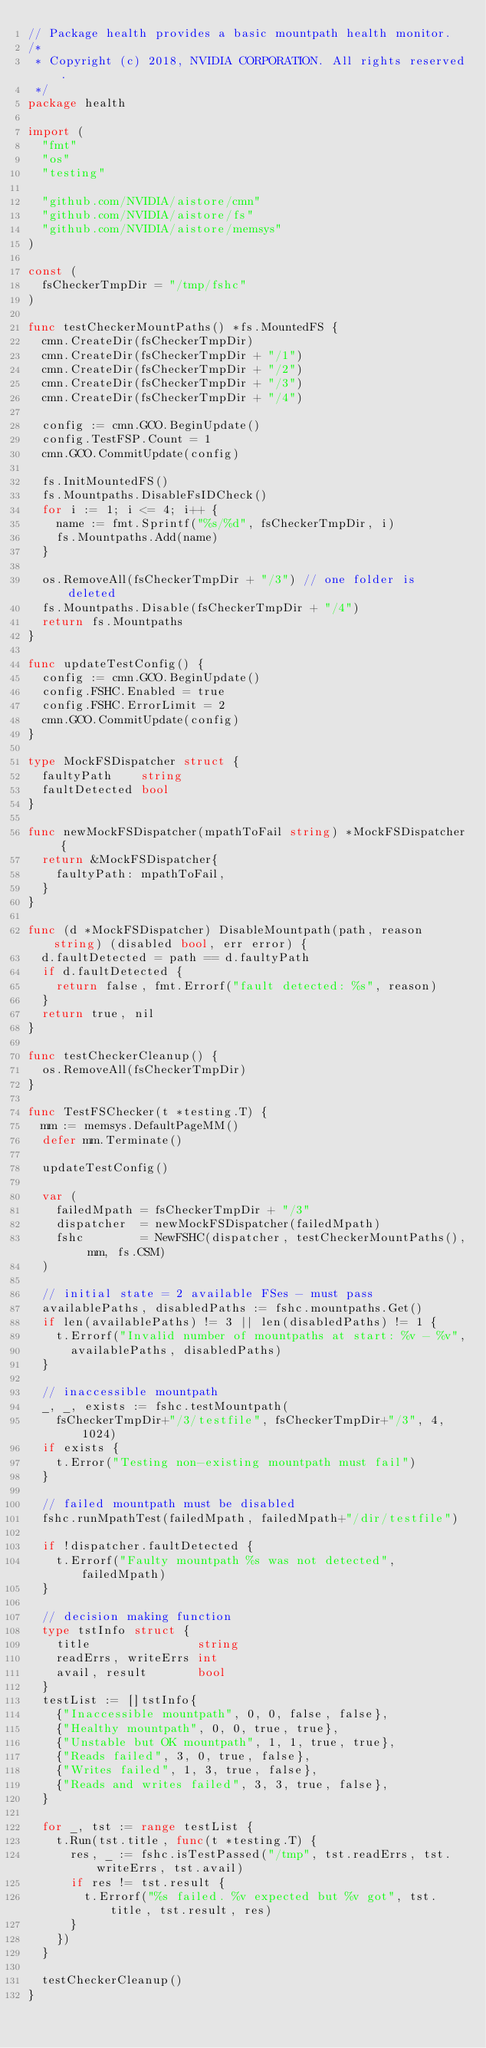<code> <loc_0><loc_0><loc_500><loc_500><_Go_>// Package health provides a basic mountpath health monitor.
/*
 * Copyright (c) 2018, NVIDIA CORPORATION. All rights reserved.
 */
package health

import (
	"fmt"
	"os"
	"testing"

	"github.com/NVIDIA/aistore/cmn"
	"github.com/NVIDIA/aistore/fs"
	"github.com/NVIDIA/aistore/memsys"
)

const (
	fsCheckerTmpDir = "/tmp/fshc"
)

func testCheckerMountPaths() *fs.MountedFS {
	cmn.CreateDir(fsCheckerTmpDir)
	cmn.CreateDir(fsCheckerTmpDir + "/1")
	cmn.CreateDir(fsCheckerTmpDir + "/2")
	cmn.CreateDir(fsCheckerTmpDir + "/3")
	cmn.CreateDir(fsCheckerTmpDir + "/4")

	config := cmn.GCO.BeginUpdate()
	config.TestFSP.Count = 1
	cmn.GCO.CommitUpdate(config)

	fs.InitMountedFS()
	fs.Mountpaths.DisableFsIDCheck()
	for i := 1; i <= 4; i++ {
		name := fmt.Sprintf("%s/%d", fsCheckerTmpDir, i)
		fs.Mountpaths.Add(name)
	}

	os.RemoveAll(fsCheckerTmpDir + "/3") // one folder is deleted
	fs.Mountpaths.Disable(fsCheckerTmpDir + "/4")
	return fs.Mountpaths
}

func updateTestConfig() {
	config := cmn.GCO.BeginUpdate()
	config.FSHC.Enabled = true
	config.FSHC.ErrorLimit = 2
	cmn.GCO.CommitUpdate(config)
}

type MockFSDispatcher struct {
	faultyPath    string
	faultDetected bool
}

func newMockFSDispatcher(mpathToFail string) *MockFSDispatcher {
	return &MockFSDispatcher{
		faultyPath: mpathToFail,
	}
}

func (d *MockFSDispatcher) DisableMountpath(path, reason string) (disabled bool, err error) {
	d.faultDetected = path == d.faultyPath
	if d.faultDetected {
		return false, fmt.Errorf("fault detected: %s", reason)
	}
	return true, nil
}

func testCheckerCleanup() {
	os.RemoveAll(fsCheckerTmpDir)
}

func TestFSChecker(t *testing.T) {
	mm := memsys.DefaultPageMM()
	defer mm.Terminate()

	updateTestConfig()

	var (
		failedMpath = fsCheckerTmpDir + "/3"
		dispatcher  = newMockFSDispatcher(failedMpath)
		fshc        = NewFSHC(dispatcher, testCheckerMountPaths(), mm, fs.CSM)
	)

	// initial state = 2 available FSes - must pass
	availablePaths, disabledPaths := fshc.mountpaths.Get()
	if len(availablePaths) != 3 || len(disabledPaths) != 1 {
		t.Errorf("Invalid number of mountpaths at start: %v - %v",
			availablePaths, disabledPaths)
	}

	// inaccessible mountpath
	_, _, exists := fshc.testMountpath(
		fsCheckerTmpDir+"/3/testfile", fsCheckerTmpDir+"/3", 4, 1024)
	if exists {
		t.Error("Testing non-existing mountpath must fail")
	}

	// failed mountpath must be disabled
	fshc.runMpathTest(failedMpath, failedMpath+"/dir/testfile")

	if !dispatcher.faultDetected {
		t.Errorf("Faulty mountpath %s was not detected", failedMpath)
	}

	// decision making function
	type tstInfo struct {
		title               string
		readErrs, writeErrs int
		avail, result       bool
	}
	testList := []tstInfo{
		{"Inaccessible mountpath", 0, 0, false, false},
		{"Healthy mountpath", 0, 0, true, true},
		{"Unstable but OK mountpath", 1, 1, true, true},
		{"Reads failed", 3, 0, true, false},
		{"Writes failed", 1, 3, true, false},
		{"Reads and writes failed", 3, 3, true, false},
	}

	for _, tst := range testList {
		t.Run(tst.title, func(t *testing.T) {
			res, _ := fshc.isTestPassed("/tmp", tst.readErrs, tst.writeErrs, tst.avail)
			if res != tst.result {
				t.Errorf("%s failed. %v expected but %v got", tst.title, tst.result, res)
			}
		})
	}

	testCheckerCleanup()
}
</code> 